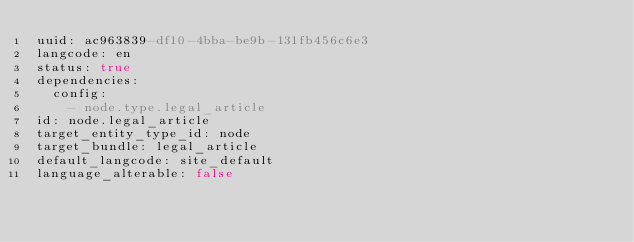<code> <loc_0><loc_0><loc_500><loc_500><_YAML_>uuid: ac963839-df10-4bba-be9b-131fb456c6e3
langcode: en
status: true
dependencies:
  config:
    - node.type.legal_article
id: node.legal_article
target_entity_type_id: node
target_bundle: legal_article
default_langcode: site_default
language_alterable: false
</code> 